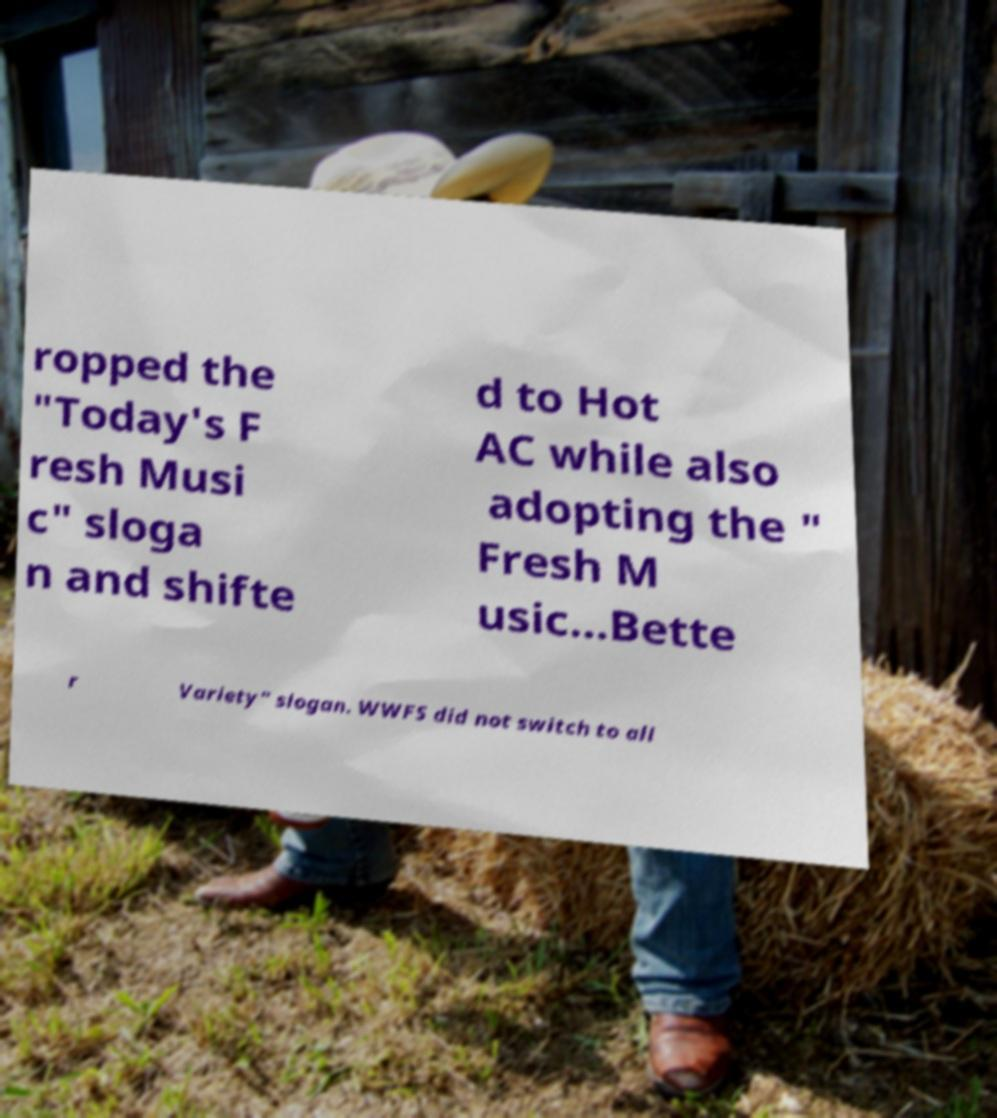Please read and relay the text visible in this image. What does it say? ropped the "Today's F resh Musi c" sloga n and shifte d to Hot AC while also adopting the " Fresh M usic...Bette r Variety" slogan. WWFS did not switch to all 